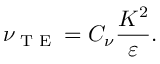<formula> <loc_0><loc_0><loc_500><loc_500>\nu _ { T E } = C _ { \nu } \frac { K ^ { 2 } } { \varepsilon } .</formula> 